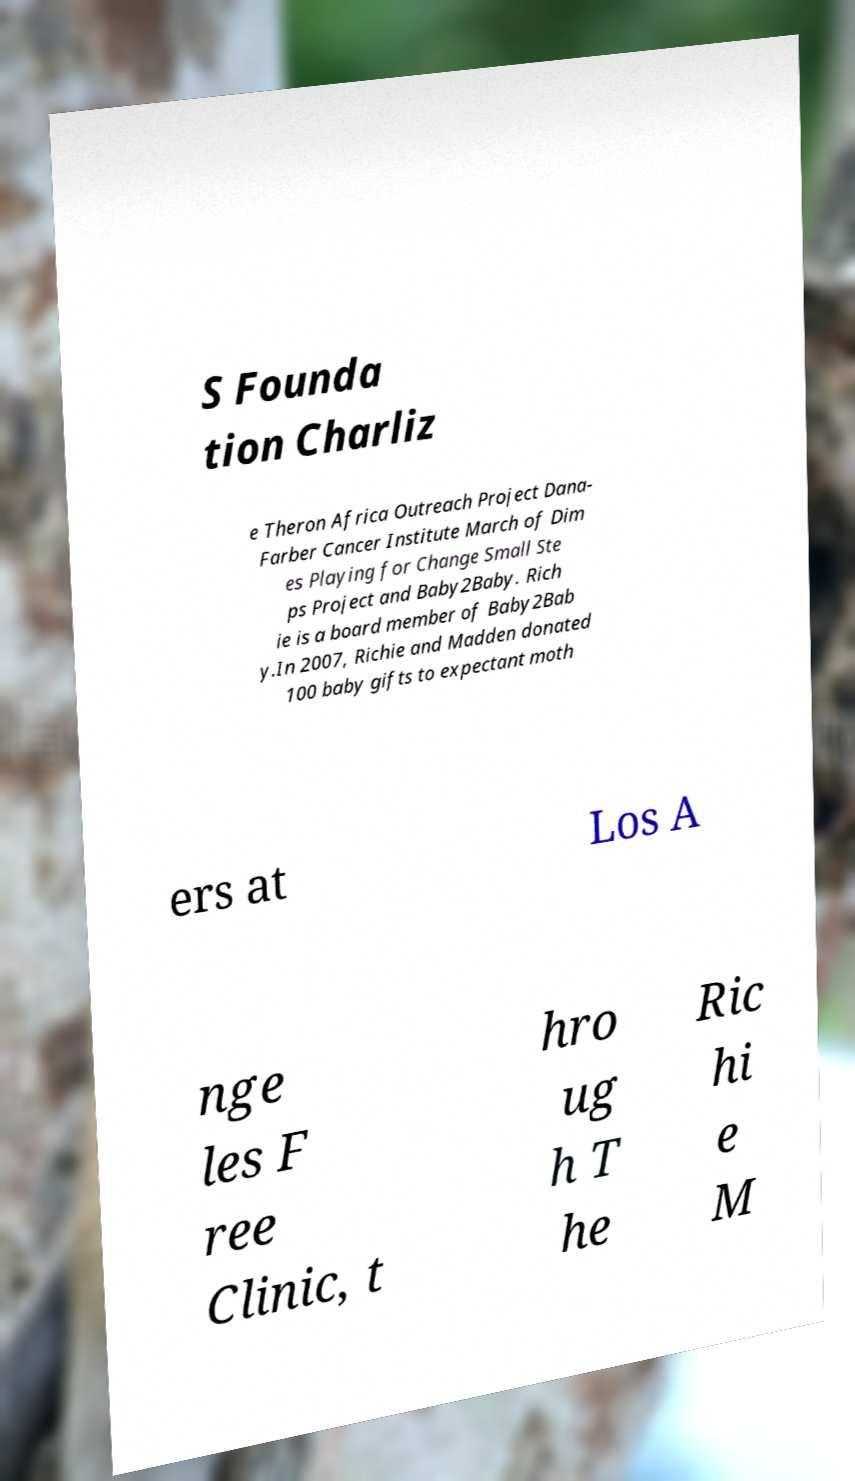For documentation purposes, I need the text within this image transcribed. Could you provide that? S Founda tion Charliz e Theron Africa Outreach Project Dana- Farber Cancer Institute March of Dim es Playing for Change Small Ste ps Project and Baby2Baby. Rich ie is a board member of Baby2Bab y.In 2007, Richie and Madden donated 100 baby gifts to expectant moth ers at Los A nge les F ree Clinic, t hro ug h T he Ric hi e M 